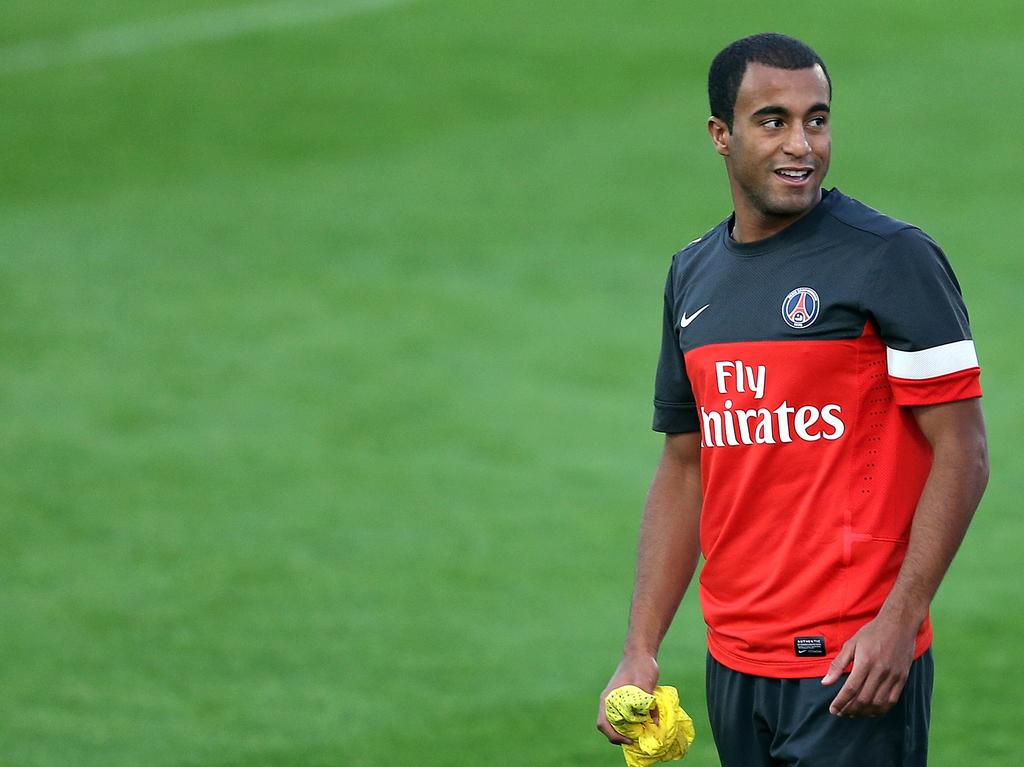What is the main subject of the image? There is a man in the image. What is the man holding in his hand? The man is holding a cloth in his hand. What type of surface is visible on the ground in the image? There is grass visible on the ground in the image. What type of smile can be seen on the man's face in the image? There is no indication of the man's facial expression in the image, so it cannot be determined if he is smiling or not. 